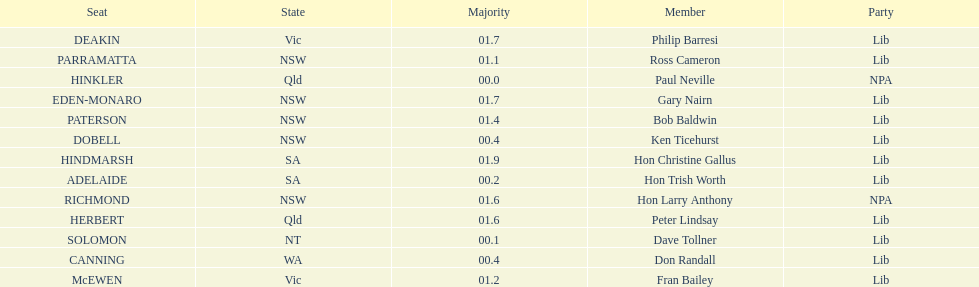How many members in total? 13. 